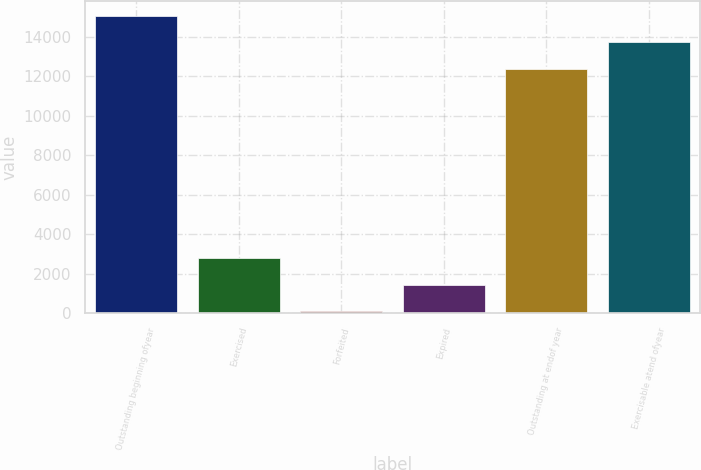Convert chart. <chart><loc_0><loc_0><loc_500><loc_500><bar_chart><fcel>Outstanding beginning ofyear<fcel>Exercised<fcel>Forfeited<fcel>Expired<fcel>Outstanding at endof year<fcel>Exercisable atend ofyear<nl><fcel>15071.4<fcel>2786.4<fcel>89<fcel>1437.7<fcel>12374<fcel>13722.7<nl></chart> 